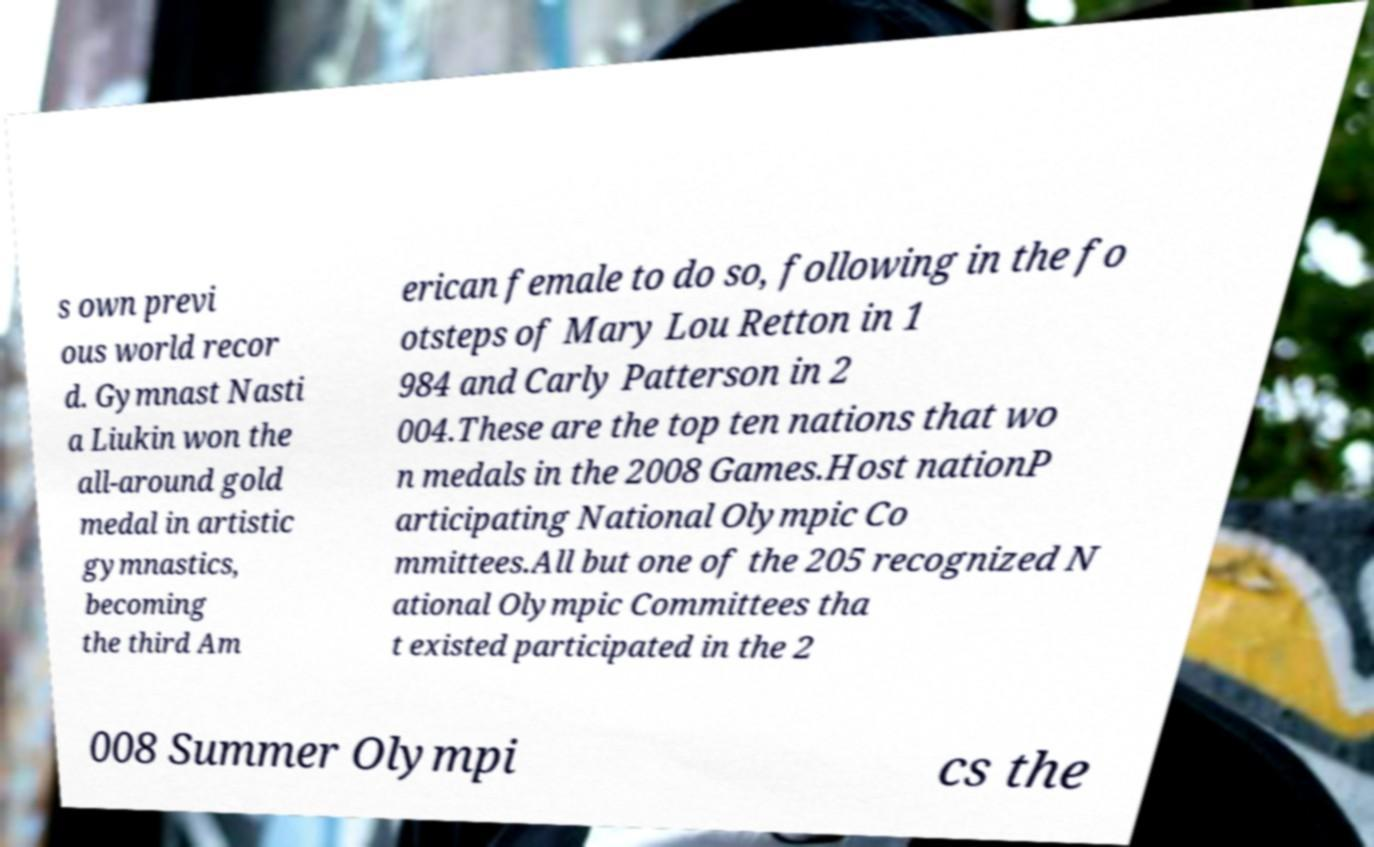Can you accurately transcribe the text from the provided image for me? s own previ ous world recor d. Gymnast Nasti a Liukin won the all-around gold medal in artistic gymnastics, becoming the third Am erican female to do so, following in the fo otsteps of Mary Lou Retton in 1 984 and Carly Patterson in 2 004.These are the top ten nations that wo n medals in the 2008 Games.Host nationP articipating National Olympic Co mmittees.All but one of the 205 recognized N ational Olympic Committees tha t existed participated in the 2 008 Summer Olympi cs the 